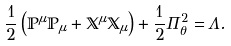Convert formula to latex. <formula><loc_0><loc_0><loc_500><loc_500>\frac { 1 } { 2 } \left ( { \mathbb { P } } ^ { \mu } { \mathbb { P } } _ { \mu } + { \mathbb { X } } ^ { \mu } { \mathbb { X } } _ { \mu } \right ) + \frac { 1 } { 2 } \Pi _ { \theta } ^ { 2 } = & \, \Lambda .</formula> 